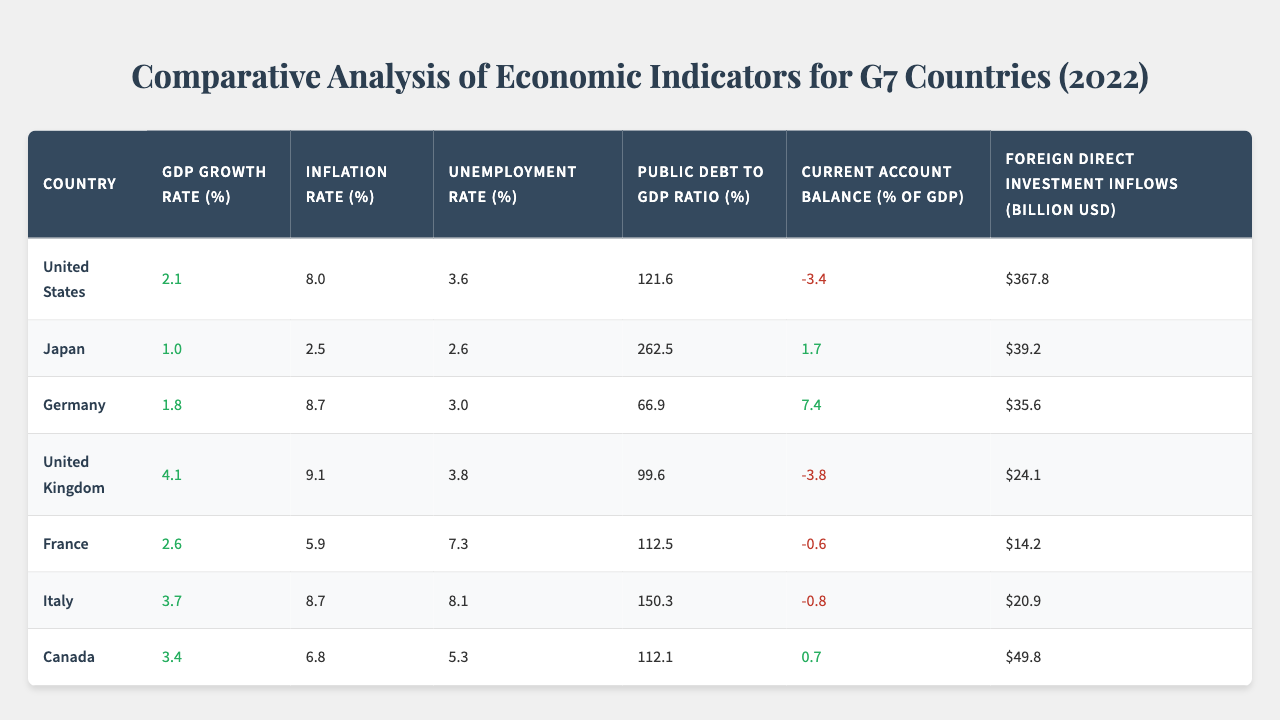What is the GDP growth rate of Germany in 2022? The table shows the GDP growth rate for Germany listed directly as 1.8%.
Answer: 1.8% Which G7 country had the highest inflation rate in 2022? By comparing the inflation rates for all G7 countries, the United Kingdom has the highest at 9.1%.
Answer: United Kingdom What was the unemployment rate in Italy during 2022? The table specifically indicates that the unemployment rate for Italy is 8.1%.
Answer: 8.1% Is the current account balance of Japan positive or negative? The current account balance for Japan is listed as 1.7%, which is a positive value.
Answer: Positive What is the average public debt to GDP ratio of the G7 countries? Adding the public debt ratios yields 121.6 + 262.5 + 66.9 + 99.6 + 112.5 + 150.3 + 112.1 = 925.5. Dividing by 7 countries gives an average of 925.5 / 7 = approximately 132.2%.
Answer: 132.2% Which country had the highest foreign direct investment inflows? By scanning the table, the United States leads with $367.8 billion in foreign direct investment inflows.
Answer: United States Was the inflation rate in Germany higher than in France? The inflation rate in Germany is 8.7%, while France's is 5.9%. Thus, yes, Germany’s inflation is higher.
Answer: Yes What is the difference in GDP growth rate between the United Kingdom and Japan? The UK has a GDP growth rate of 4.1%, and Japan has 1.0%. The difference is 4.1 - 1.0 = 3.1%.
Answer: 3.1% How many G7 countries had a current account balance that was negative? Examining the table, both the United States and the United Kingdom have negative current account balances, along with France and Italy, totaling four countries.
Answer: Four Which country has both the highest public debt to GDP ratio and the lowest unemployment rate? Japan has the highest public debt to GDP ratio at 262.5%, while it also has the lowest unemployment rate of 2.6%.
Answer: Japan 